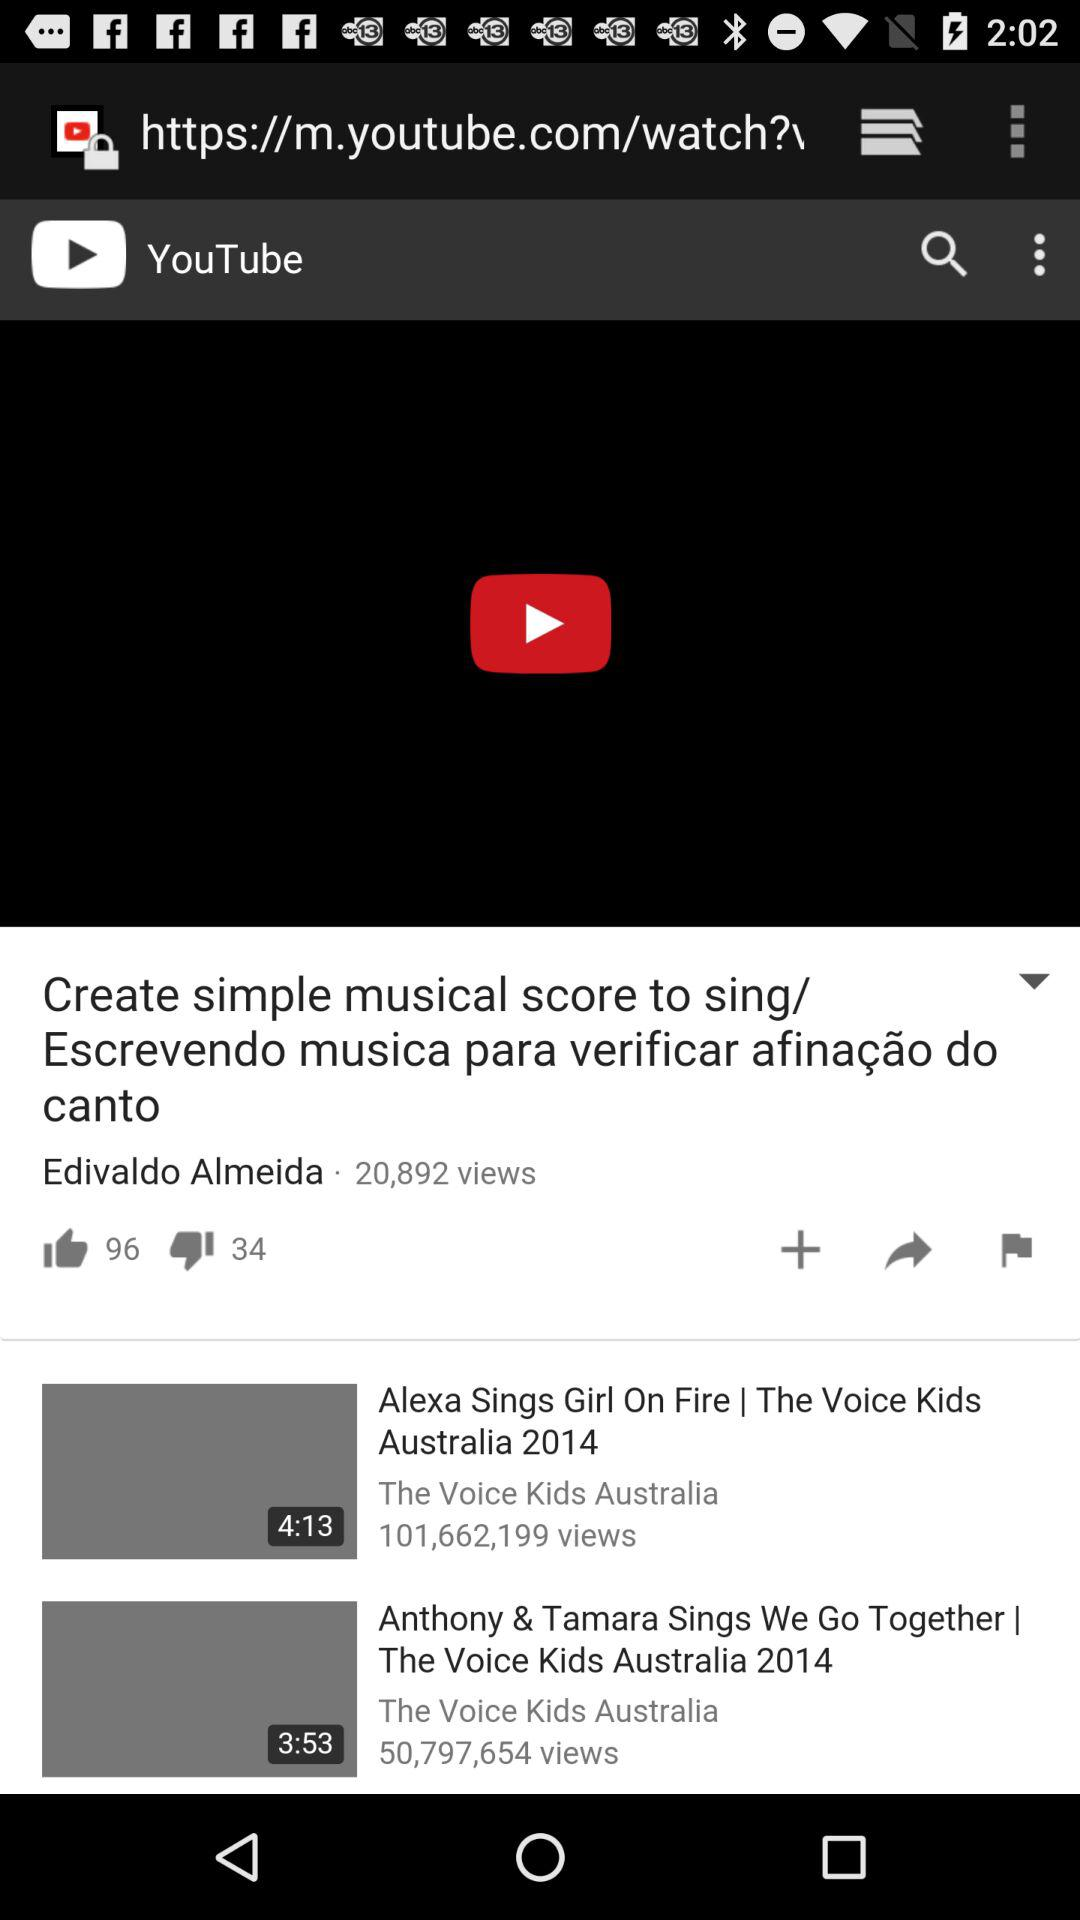Which video has a duration of 4:13 minutes? The video that has a duration of 4 minutes 13 seconds is "Alexa Sings Girl On Fire | The Voice Kids Australia 2014". 